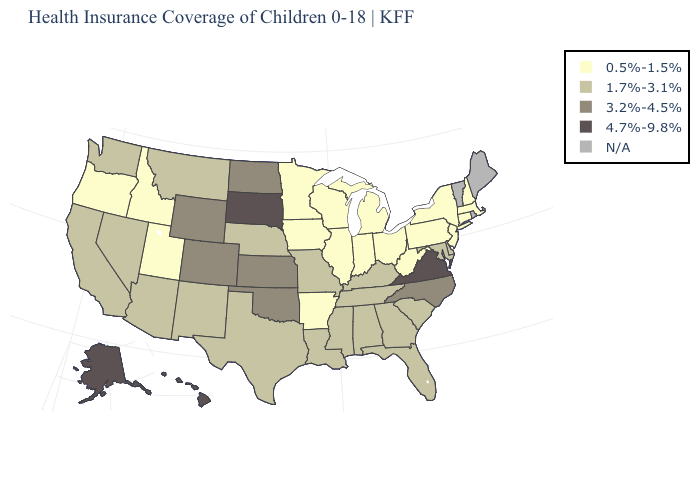Does Arkansas have the lowest value in the South?
Quick response, please. Yes. Name the states that have a value in the range 1.7%-3.1%?
Keep it brief. Alabama, Arizona, California, Delaware, Florida, Georgia, Kentucky, Louisiana, Maryland, Mississippi, Missouri, Montana, Nebraska, Nevada, New Mexico, South Carolina, Tennessee, Texas, Washington. Does the first symbol in the legend represent the smallest category?
Give a very brief answer. Yes. Name the states that have a value in the range N/A?
Quick response, please. Maine, Rhode Island, Vermont. Does the first symbol in the legend represent the smallest category?
Concise answer only. Yes. What is the highest value in the USA?
Keep it brief. 4.7%-9.8%. Name the states that have a value in the range 1.7%-3.1%?
Quick response, please. Alabama, Arizona, California, Delaware, Florida, Georgia, Kentucky, Louisiana, Maryland, Mississippi, Missouri, Montana, Nebraska, Nevada, New Mexico, South Carolina, Tennessee, Texas, Washington. Does Minnesota have the lowest value in the MidWest?
Keep it brief. Yes. What is the value of Colorado?
Answer briefly. 3.2%-4.5%. Among the states that border Indiana , which have the highest value?
Keep it brief. Kentucky. Name the states that have a value in the range 0.5%-1.5%?
Short answer required. Arkansas, Connecticut, Idaho, Illinois, Indiana, Iowa, Massachusetts, Michigan, Minnesota, New Hampshire, New Jersey, New York, Ohio, Oregon, Pennsylvania, Utah, West Virginia, Wisconsin. Which states hav the highest value in the MidWest?
Give a very brief answer. South Dakota. What is the highest value in the USA?
Write a very short answer. 4.7%-9.8%. Name the states that have a value in the range N/A?
Concise answer only. Maine, Rhode Island, Vermont. Name the states that have a value in the range 4.7%-9.8%?
Keep it brief. Alaska, Hawaii, South Dakota, Virginia. 